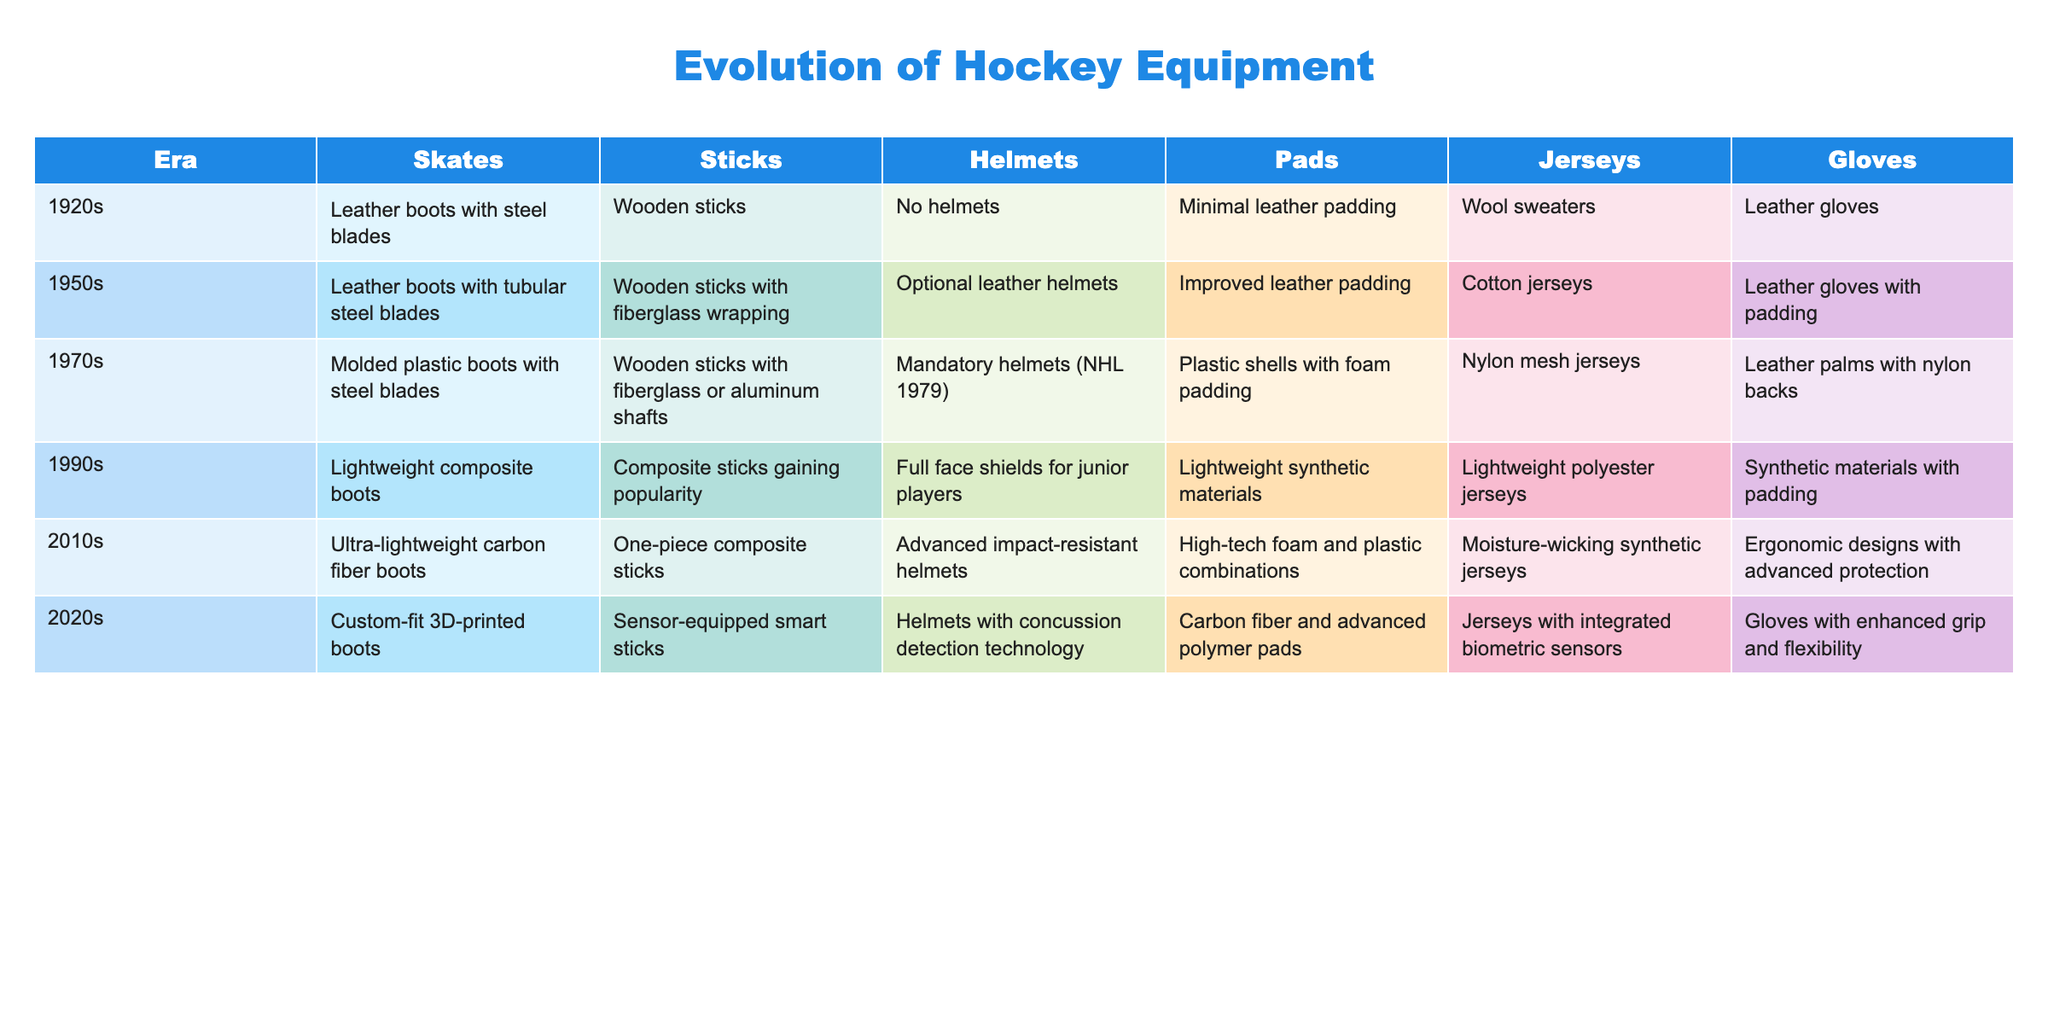What kind of gloves were used in the 1950s? In the 1950s, the gloves used were leather gloves with padding. This can be directly found in the "Gloves" column corresponding to the "1950s" row.
Answer: Leather gloves with padding Did the 1970s see the introduction of mandatory helmets in the NHL? The table indicates that helmets became mandatory in the NHL in 1979, as stated in the "Helmets" column for the 1970s row. Therefore, the answer is yes.
Answer: Yes Which era had the most advanced stick technology? The 2020s era had sensor-equipped smart sticks, indicating significant advancements compared to the previous decades, making it the most advanced. This is compared across the "Sticks" column for each era.
Answer: 2020s What is the difference in jersey material between the 1970s and 1990s? In the 1970s, jerseys were made of nylon mesh, while by the 1990s they transitioned to lightweight polyester. The difference in materials shows a change in fabric technology from mesh to polyester.
Answer: Nylon mesh vs. lightweight polyester How many eras had helmets that were optional or mandatory? From the table, looking at the "Helmets" column, it is clear that in the 1950s helmets were optional, while in the 1970s they became mandatory (NHL 1979). Thus, there are 2 eras with this distinction.
Answer: 2 eras What improvements were made in skate technology from the 1920s to the 2010s? The table outlines that skates evolved from leather boots with steel blades in the 1920s to ultra-lightweight carbon fiber boots in the 2010s. This indicates a shift toward lighter and more advanced materials for performance.
Answer: Significant improvements in weight and material technology Were helmets first used in the 1990s? According to the table, helmets were optional in the 1950s and became mandatory in the 1970s, so they were not first used in the 1990s. Thus, the statement is false.
Answer: No Which decade introduced custom-fit boots? The 2020s saw the introduction of custom-fit 3D-printed boots as per the "Skates" column in that row, indicating this advancement emerged in that decade.
Answer: 2020s What type of padding was used in helmets from the 2010s? The 2010s era specified helmets used advanced impact-resistant technologies, emphasizing better safety compared to earlier decades. This is clear in the "Helmets" column for that decade.
Answer: Advanced impact-resistant technology 